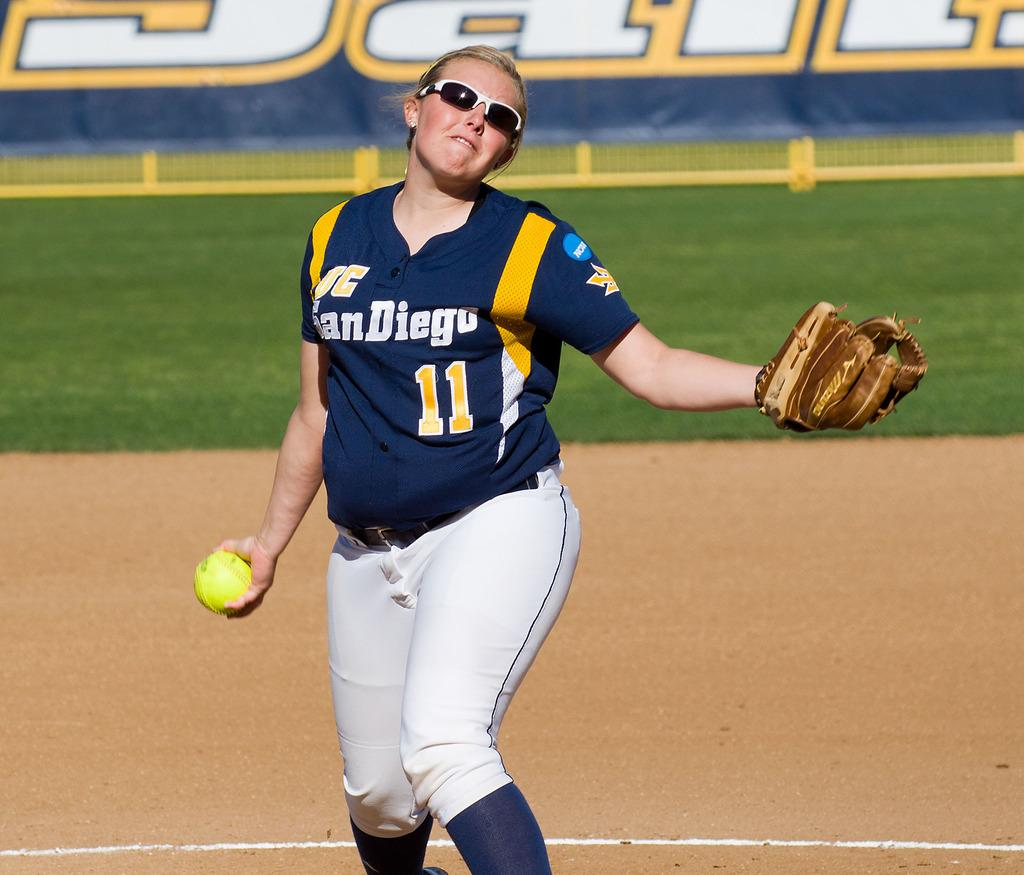<image>
Give a short and clear explanation of the subsequent image. a player with the words san diego on their jersey 